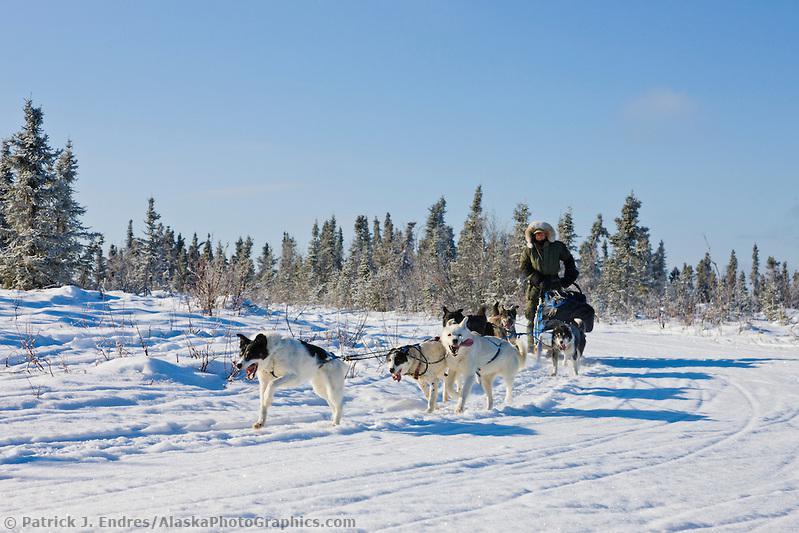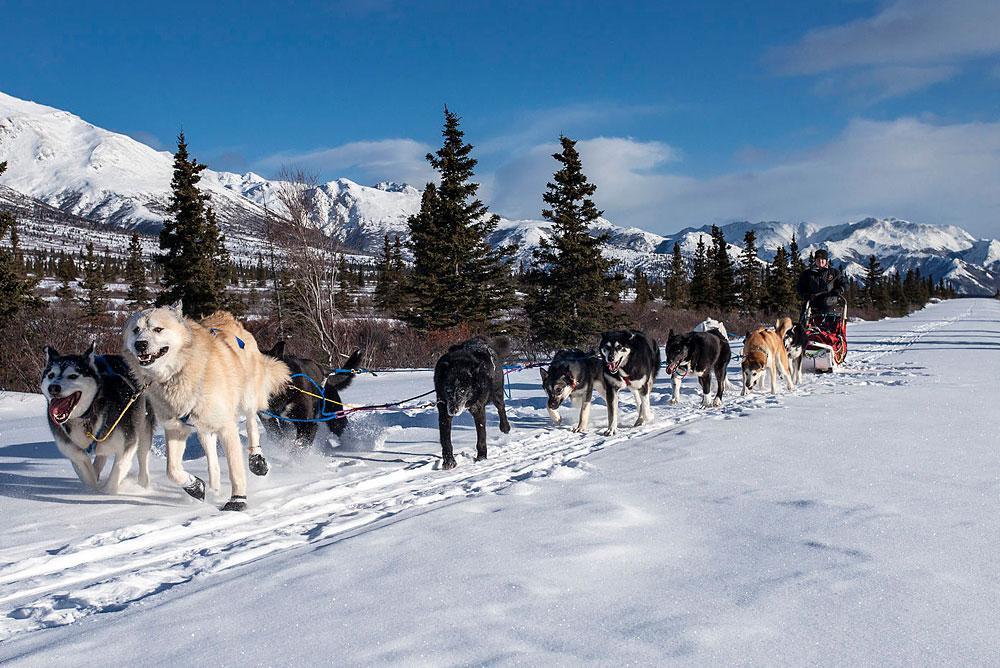The first image is the image on the left, the second image is the image on the right. For the images shown, is this caption "All dog sled teams are heading diagonally to the left with evergreen trees in the background." true? Answer yes or no. Yes. The first image is the image on the left, the second image is the image on the right. For the images shown, is this caption "In at least one image there are at least five snow dogs leading a man in a red coat on the sled." true? Answer yes or no. No. 